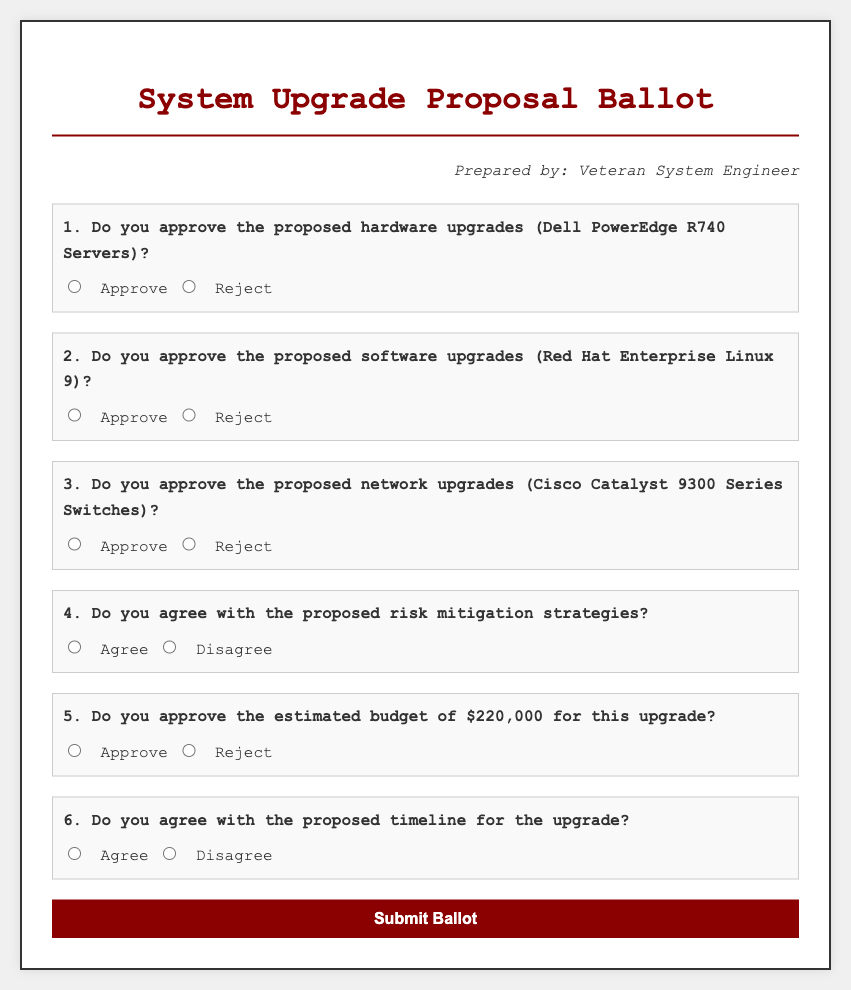What is the title of the document? The title is the main heading shown at the top of the document, which is "System Upgrade Proposal Ballot".
Answer: System Upgrade Proposal Ballot Who prepared the document? The author's name is provided in the document, specifically listed under "Prepared by".
Answer: Veteran System Engineer What is the proposed hardware upgrade? The document outlines specific hardware proposals, which is stated in the first question.
Answer: Dell PowerEdge R740 Servers What is the estimated budget for the upgrade? The budget amount is specifically mentioned in the fifth question.
Answer: $220,000 What type of software upgrade is being proposed? The type of software proposed is indicated in the second question.
Answer: Red Hat Enterprise Linux 9 How many total questions are on the ballot? The total number of questions can be counted from the document.
Answer: 6 What are voters asked to agree with regarding risk? The question in the document specifically asks about consensus related to risk strategies.
Answer: Proposed risk mitigation strategies Is the document interactive? The inclusion of a form suggests interaction for submitting feedback.
Answer: Yes 